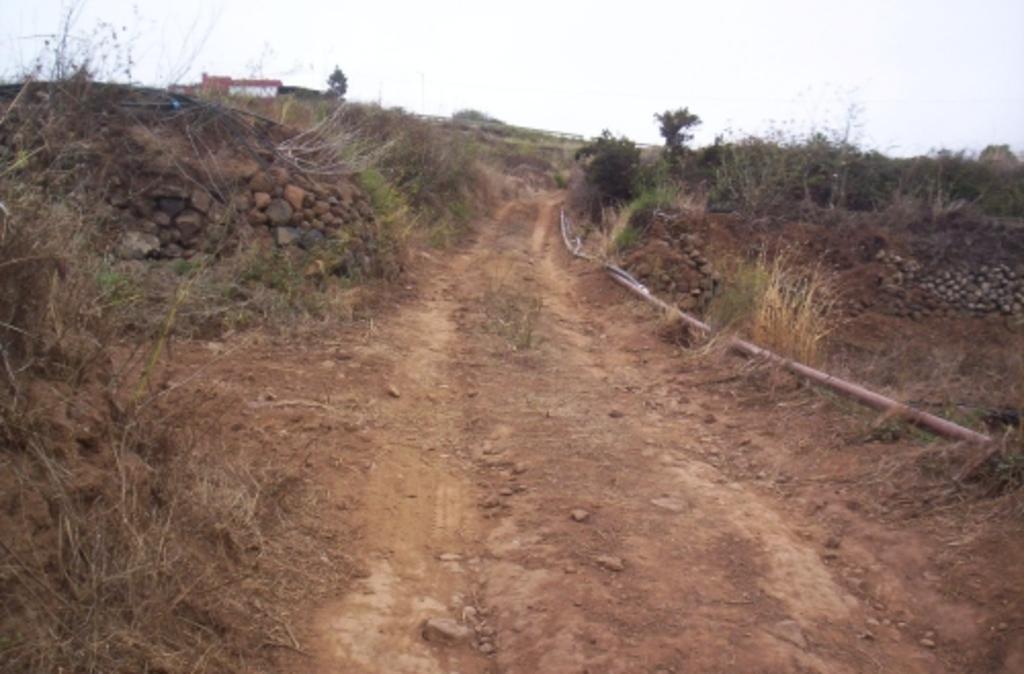Please provide a concise description of this image. In the image we can see some plants, grass, stones, trees and building. At the top of the image there is sky. 